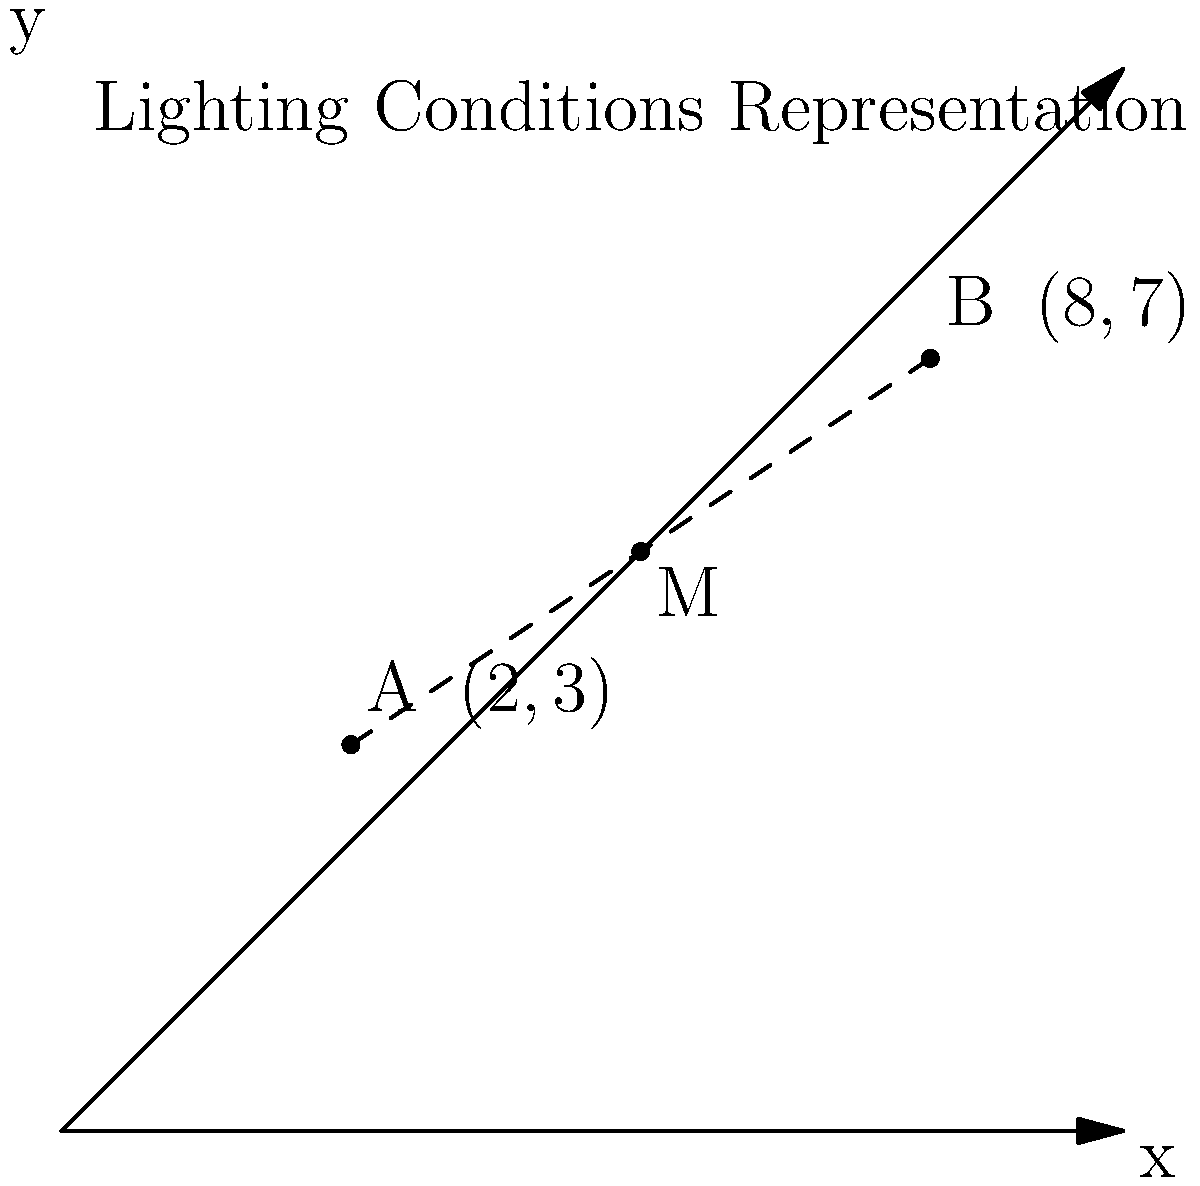In a photo shoot, two lighting conditions are represented by points A(2,3) and B(8,7) on a coordinate plane. The midpoint M between these two conditions represents the average lighting setting. What are the coordinates of point M? To find the midpoint M between two points A(x₁, y₁) and B(x₂, y₂), we use the midpoint formula:

$$ M = (\frac{x_1 + x_2}{2}, \frac{y_1 + y_2}{2}) $$

Given:
- Point A: (2, 3)
- Point B: (8, 7)

Step 1: Calculate the x-coordinate of the midpoint:
$$ x_M = \frac{x_1 + x_2}{2} = \frac{2 + 8}{2} = \frac{10}{2} = 5 $$

Step 2: Calculate the y-coordinate of the midpoint:
$$ y_M = \frac{y_1 + y_2}{2} = \frac{3 + 7}{2} = \frac{10}{2} = 5 $$

Therefore, the coordinates of the midpoint M are (5, 5).
Answer: (5, 5) 